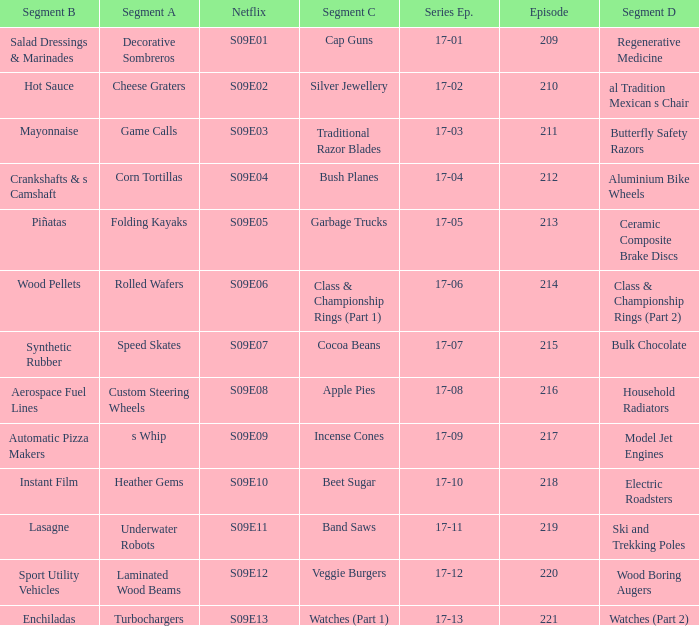Episode smaller than 210 had what segment c? Cap Guns. 